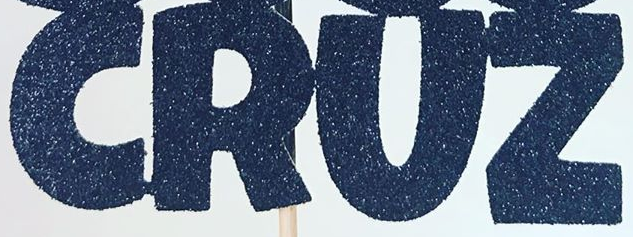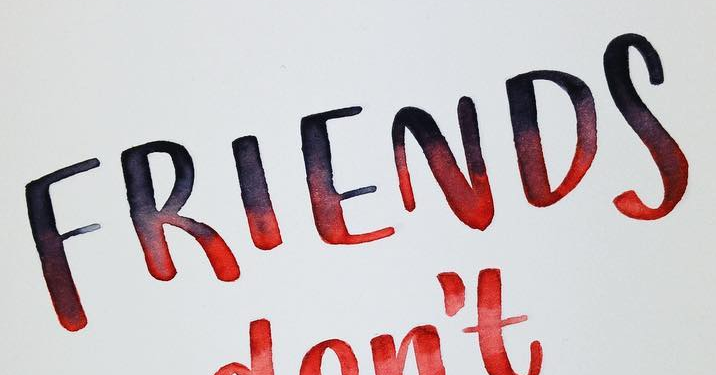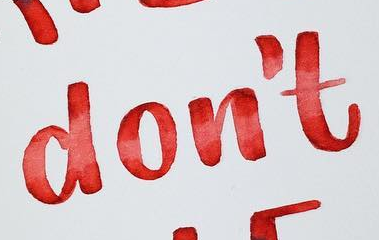What words can you see in these images in sequence, separated by a semicolon? CRUZ; FRIENDS; don't 